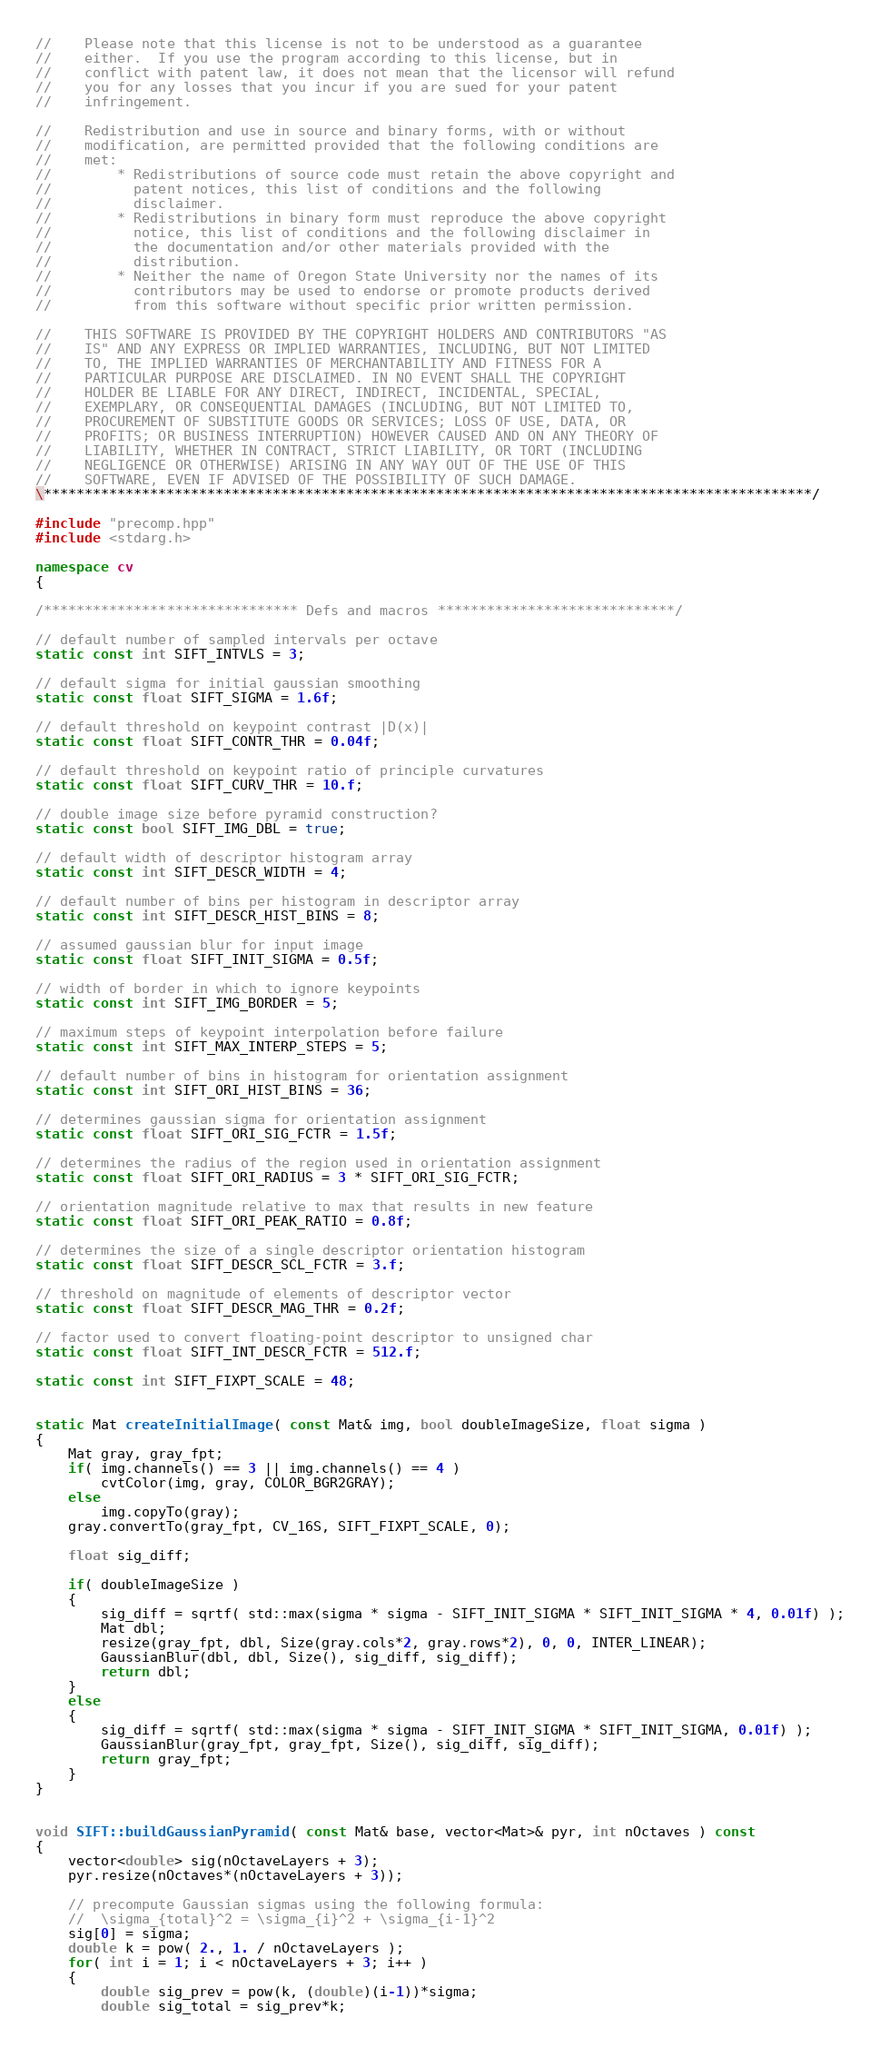Convert code to text. <code><loc_0><loc_0><loc_500><loc_500><_C++_>
//    Please note that this license is not to be understood as a guarantee
//    either.  If you use the program according to this license, but in
//    conflict with patent law, it does not mean that the licensor will refund
//    you for any losses that you incur if you are sued for your patent
//    infringement.

//    Redistribution and use in source and binary forms, with or without
//    modification, are permitted provided that the following conditions are
//    met:
//        * Redistributions of source code must retain the above copyright and
//          patent notices, this list of conditions and the following
//          disclaimer.
//        * Redistributions in binary form must reproduce the above copyright
//          notice, this list of conditions and the following disclaimer in
//          the documentation and/or other materials provided with the
//          distribution.
//        * Neither the name of Oregon State University nor the names of its
//          contributors may be used to endorse or promote products derived
//          from this software without specific prior written permission.

//    THIS SOFTWARE IS PROVIDED BY THE COPYRIGHT HOLDERS AND CONTRIBUTORS "AS
//    IS" AND ANY EXPRESS OR IMPLIED WARRANTIES, INCLUDING, BUT NOT LIMITED
//    TO, THE IMPLIED WARRANTIES OF MERCHANTABILITY AND FITNESS FOR A
//    PARTICULAR PURPOSE ARE DISCLAIMED. IN NO EVENT SHALL THE COPYRIGHT
//    HOLDER BE LIABLE FOR ANY DIRECT, INDIRECT, INCIDENTAL, SPECIAL,
//    EXEMPLARY, OR CONSEQUENTIAL DAMAGES (INCLUDING, BUT NOT LIMITED TO,
//    PROCUREMENT OF SUBSTITUTE GOODS OR SERVICES; LOSS OF USE, DATA, OR
//    PROFITS; OR BUSINESS INTERRUPTION) HOWEVER CAUSED AND ON ANY THEORY OF
//    LIABILITY, WHETHER IN CONTRACT, STRICT LIABILITY, OR TORT (INCLUDING
//    NEGLIGENCE OR OTHERWISE) ARISING IN ANY WAY OUT OF THE USE OF THIS
//    SOFTWARE, EVEN IF ADVISED OF THE POSSIBILITY OF SUCH DAMAGE.
\**********************************************************************************************/
 
#include "precomp.hpp"
#include <stdarg.h>

namespace cv
{

/******************************* Defs and macros *****************************/

// default number of sampled intervals per octave
static const int SIFT_INTVLS = 3;

// default sigma for initial gaussian smoothing
static const float SIFT_SIGMA = 1.6f;

// default threshold on keypoint contrast |D(x)|
static const float SIFT_CONTR_THR = 0.04f;

// default threshold on keypoint ratio of principle curvatures
static const float SIFT_CURV_THR = 10.f;

// double image size before pyramid construction?
static const bool SIFT_IMG_DBL = true;

// default width of descriptor histogram array
static const int SIFT_DESCR_WIDTH = 4;

// default number of bins per histogram in descriptor array
static const int SIFT_DESCR_HIST_BINS = 8;

// assumed gaussian blur for input image
static const float SIFT_INIT_SIGMA = 0.5f;

// width of border in which to ignore keypoints
static const int SIFT_IMG_BORDER = 5;

// maximum steps of keypoint interpolation before failure
static const int SIFT_MAX_INTERP_STEPS = 5;

// default number of bins in histogram for orientation assignment
static const int SIFT_ORI_HIST_BINS = 36;

// determines gaussian sigma for orientation assignment
static const float SIFT_ORI_SIG_FCTR = 1.5f;

// determines the radius of the region used in orientation assignment
static const float SIFT_ORI_RADIUS = 3 * SIFT_ORI_SIG_FCTR;

// orientation magnitude relative to max that results in new feature
static const float SIFT_ORI_PEAK_RATIO = 0.8f;

// determines the size of a single descriptor orientation histogram
static const float SIFT_DESCR_SCL_FCTR = 3.f;

// threshold on magnitude of elements of descriptor vector
static const float SIFT_DESCR_MAG_THR = 0.2f;

// factor used to convert floating-point descriptor to unsigned char
static const float SIFT_INT_DESCR_FCTR = 512.f;
    
static const int SIFT_FIXPT_SCALE = 48;
    
    
static Mat createInitialImage( const Mat& img, bool doubleImageSize, float sigma )
{
    Mat gray, gray_fpt;
    if( img.channels() == 3 || img.channels() == 4 )
        cvtColor(img, gray, COLOR_BGR2GRAY);
    else
        img.copyTo(gray);
    gray.convertTo(gray_fpt, CV_16S, SIFT_FIXPT_SCALE, 0);
    
    float sig_diff;
    
    if( doubleImageSize )
    {
        sig_diff = sqrtf( std::max(sigma * sigma - SIFT_INIT_SIGMA * SIFT_INIT_SIGMA * 4, 0.01f) );
        Mat dbl;
        resize(gray_fpt, dbl, Size(gray.cols*2, gray.rows*2), 0, 0, INTER_LINEAR);
        GaussianBlur(dbl, dbl, Size(), sig_diff, sig_diff);
        return dbl;
    }
    else
    {
        sig_diff = sqrtf( std::max(sigma * sigma - SIFT_INIT_SIGMA * SIFT_INIT_SIGMA, 0.01f) );
        GaussianBlur(gray_fpt, gray_fpt, Size(), sig_diff, sig_diff);
        return gray_fpt;
    }
}
    
    
void SIFT::buildGaussianPyramid( const Mat& base, vector<Mat>& pyr, int nOctaves ) const
{
    vector<double> sig(nOctaveLayers + 3);
    pyr.resize(nOctaves*(nOctaveLayers + 3));
    
    // precompute Gaussian sigmas using the following formula:
    //  \sigma_{total}^2 = \sigma_{i}^2 + \sigma_{i-1}^2
    sig[0] = sigma;
    double k = pow( 2., 1. / nOctaveLayers );
    for( int i = 1; i < nOctaveLayers + 3; i++ )
    {
        double sig_prev = pow(k, (double)(i-1))*sigma;
        double sig_total = sig_prev*k;</code> 